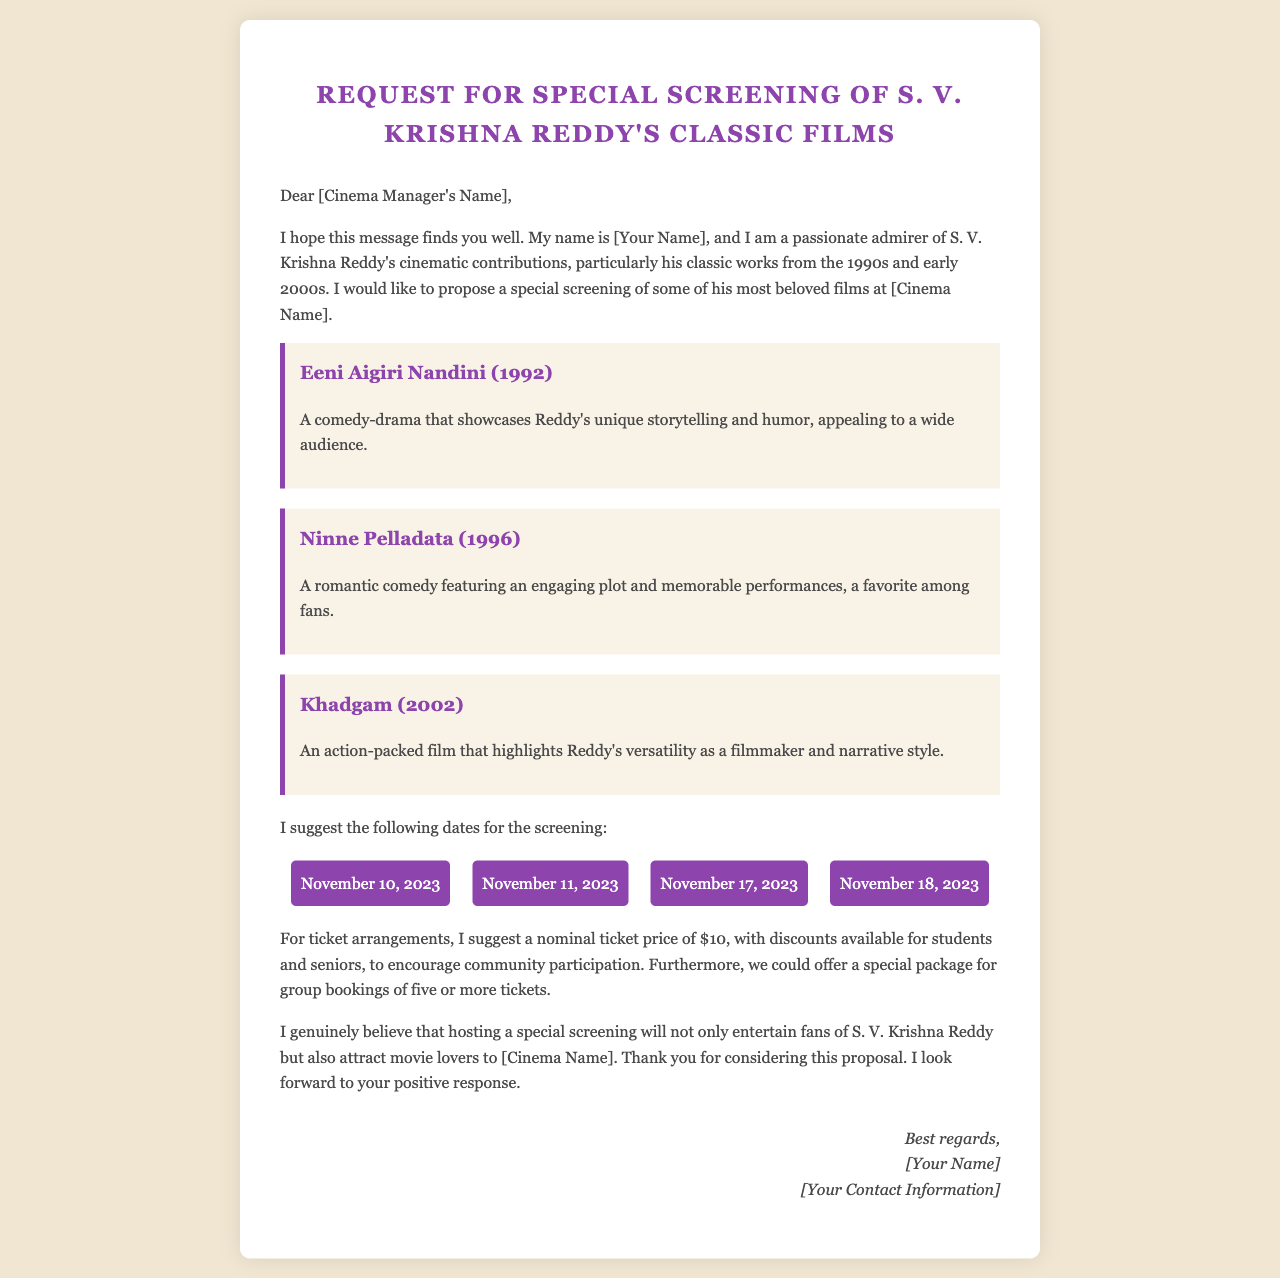What is the title of the letter? The title of the letter is stated at the top of the document.
Answer: Request for Special Screening of S. V. Krishna Reddy's Classic Films Who is the author of the letter? The author introduces themselves at the beginning of the letter.
Answer: [Your Name] What are the suggested screening dates? The screening dates are listed in a section of the letter.
Answer: November 10, 2023; November 11, 2023; November 17, 2023; November 18, 2023 How much is the nominal ticket price? The ticket price is mentioned in the section discussing ticket arrangements.
Answer: $10 What is one of the suggested films for screening? The letter lists several films to be screened, which are mentioned in their own sections.
Answer: Eeni Aigiri Nandini (1992) What type of discounts is mentioned for ticket sales? The letter notes specific groups that might receive discounts on tickets.
Answer: Students and seniors Why does the author believe the screening will benefit the cinema? The author provides reasoning for how the screening can enhance community participation.
Answer: Attract movie lovers What is the suggested arrangement for group bookings? The letter outlines a proposal for group ticket purchases to encourage attendance.
Answer: Special package for group bookings of five or more tickets What is the main purpose of this letter? The author clearly states their intent at the beginning of the letter.
Answer: Request a special screening 